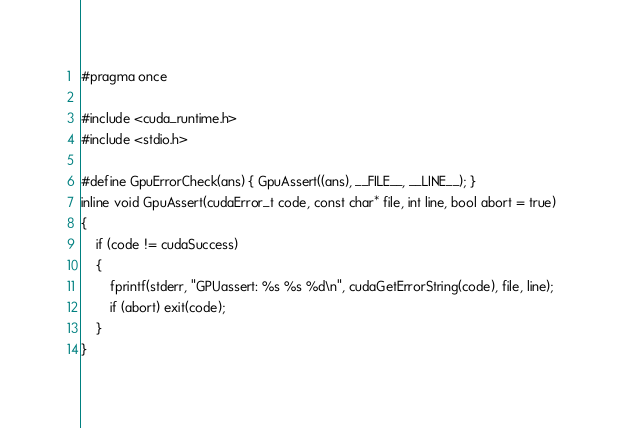Convert code to text. <code><loc_0><loc_0><loc_500><loc_500><_Cuda_>#pragma once

#include <cuda_runtime.h>
#include <stdio.h>

#define GpuErrorCheck(ans) { GpuAssert((ans), __FILE__, __LINE__); }
inline void GpuAssert(cudaError_t code, const char* file, int line, bool abort = true)
{
	if (code != cudaSuccess)
	{
		fprintf(stderr, "GPUassert: %s %s %d\n", cudaGetErrorString(code), file, line);
		if (abort) exit(code);
	}
}</code> 